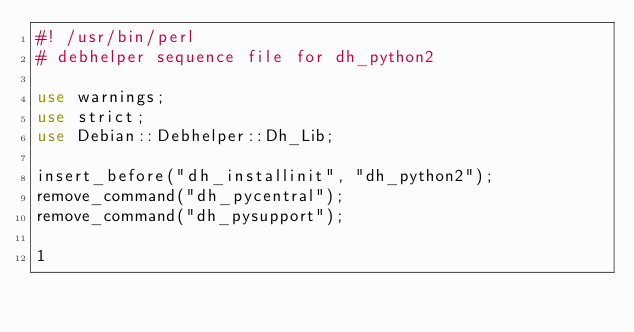<code> <loc_0><loc_0><loc_500><loc_500><_Perl_>#! /usr/bin/perl
# debhelper sequence file for dh_python2

use warnings;
use strict;
use Debian::Debhelper::Dh_Lib;

insert_before("dh_installinit", "dh_python2");
remove_command("dh_pycentral");
remove_command("dh_pysupport");

1
</code> 